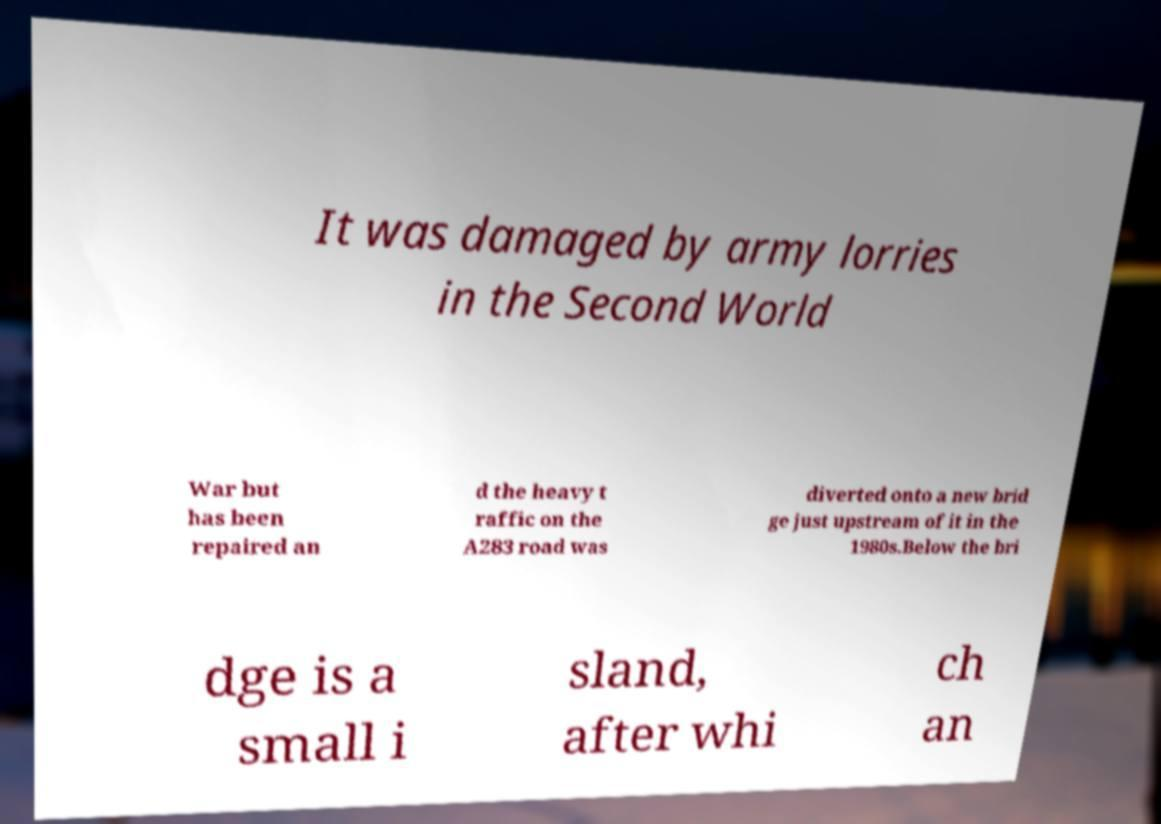Could you extract and type out the text from this image? It was damaged by army lorries in the Second World War but has been repaired an d the heavy t raffic on the A283 road was diverted onto a new brid ge just upstream of it in the 1980s.Below the bri dge is a small i sland, after whi ch an 